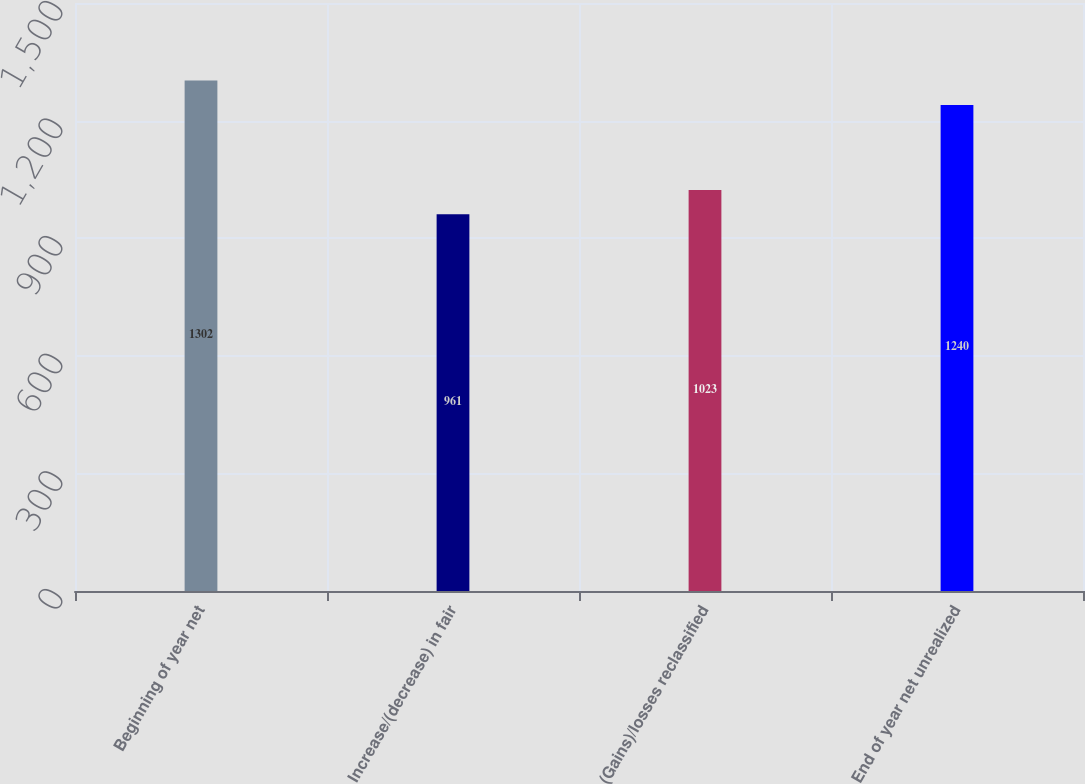Convert chart to OTSL. <chart><loc_0><loc_0><loc_500><loc_500><bar_chart><fcel>Beginning of year net<fcel>Increase/(decrease) in fair<fcel>(Gains)/losses reclassified<fcel>End of year net unrealized<nl><fcel>1302<fcel>961<fcel>1023<fcel>1240<nl></chart> 